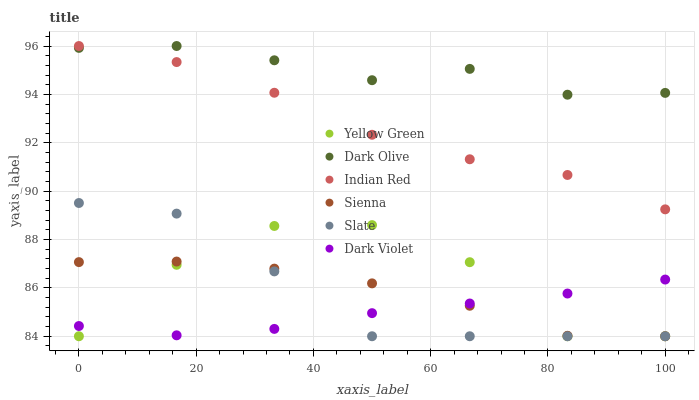Does Dark Violet have the minimum area under the curve?
Answer yes or no. Yes. Does Dark Olive have the maximum area under the curve?
Answer yes or no. Yes. Does Slate have the minimum area under the curve?
Answer yes or no. No. Does Slate have the maximum area under the curve?
Answer yes or no. No. Is Dark Violet the smoothest?
Answer yes or no. Yes. Is Yellow Green the roughest?
Answer yes or no. Yes. Is Slate the smoothest?
Answer yes or no. No. Is Slate the roughest?
Answer yes or no. No. Does Yellow Green have the lowest value?
Answer yes or no. Yes. Does Dark Olive have the lowest value?
Answer yes or no. No. Does Indian Red have the highest value?
Answer yes or no. Yes. Does Slate have the highest value?
Answer yes or no. No. Is Dark Violet less than Dark Olive?
Answer yes or no. Yes. Is Dark Olive greater than Yellow Green?
Answer yes or no. Yes. Does Slate intersect Yellow Green?
Answer yes or no. Yes. Is Slate less than Yellow Green?
Answer yes or no. No. Is Slate greater than Yellow Green?
Answer yes or no. No. Does Dark Violet intersect Dark Olive?
Answer yes or no. No. 